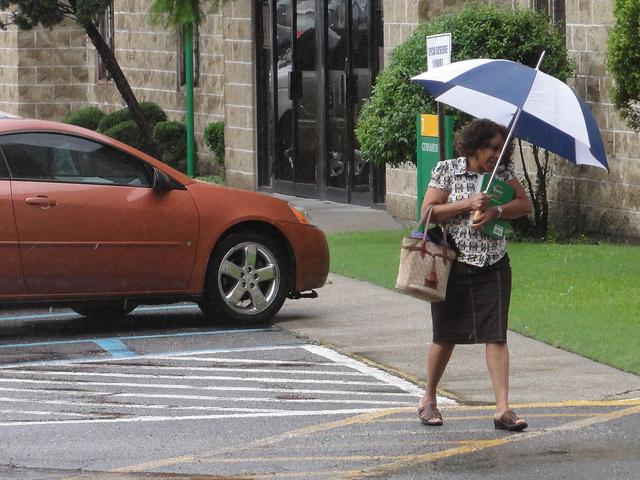What two primary colors have to be combined to get the color of the car? red yellow 